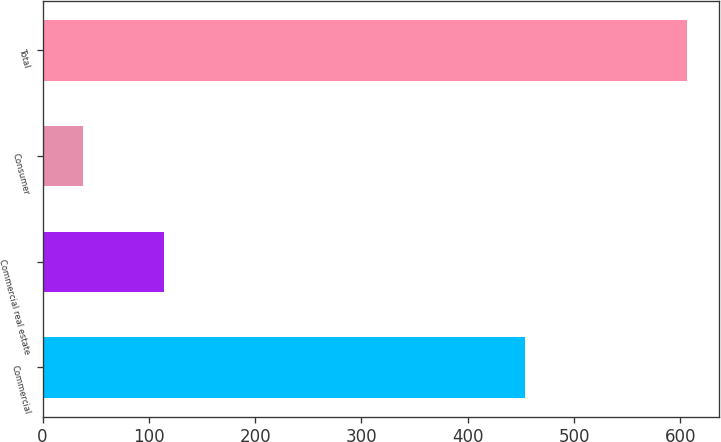Convert chart to OTSL. <chart><loc_0><loc_0><loc_500><loc_500><bar_chart><fcel>Commercial<fcel>Commercial real estate<fcel>Consumer<fcel>Total<nl><fcel>454<fcel>114<fcel>38<fcel>606<nl></chart> 